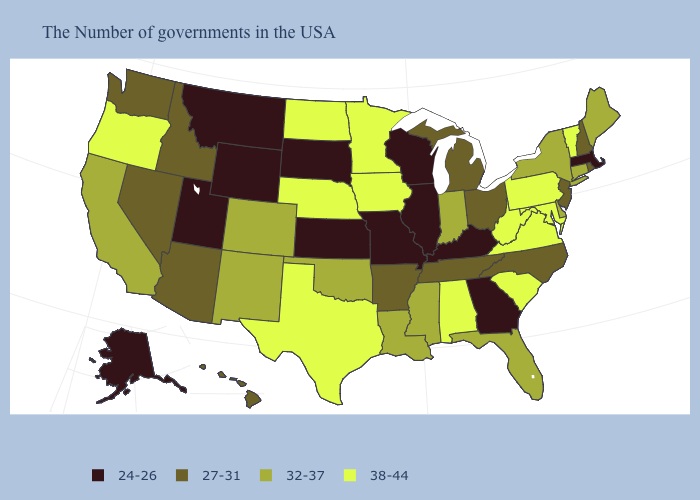Among the states that border Virginia , does Kentucky have the lowest value?
Write a very short answer. Yes. What is the lowest value in states that border North Dakota?
Give a very brief answer. 24-26. Among the states that border Iowa , which have the highest value?
Short answer required. Minnesota, Nebraska. Among the states that border Missouri , which have the highest value?
Be succinct. Iowa, Nebraska. What is the value of Washington?
Concise answer only. 27-31. What is the lowest value in the South?
Keep it brief. 24-26. Which states have the lowest value in the USA?
Keep it brief. Massachusetts, Georgia, Kentucky, Wisconsin, Illinois, Missouri, Kansas, South Dakota, Wyoming, Utah, Montana, Alaska. Which states have the highest value in the USA?
Be succinct. Vermont, Maryland, Pennsylvania, Virginia, South Carolina, West Virginia, Alabama, Minnesota, Iowa, Nebraska, Texas, North Dakota, Oregon. Does Nevada have the lowest value in the USA?
Concise answer only. No. Does West Virginia have the highest value in the South?
Quick response, please. Yes. Does Mississippi have the lowest value in the USA?
Keep it brief. No. Which states hav the highest value in the West?
Concise answer only. Oregon. Name the states that have a value in the range 32-37?
Be succinct. Maine, Connecticut, New York, Delaware, Florida, Indiana, Mississippi, Louisiana, Oklahoma, Colorado, New Mexico, California. Among the states that border Virginia , which have the highest value?
Be succinct. Maryland, West Virginia. Among the states that border Illinois , which have the highest value?
Be succinct. Iowa. 